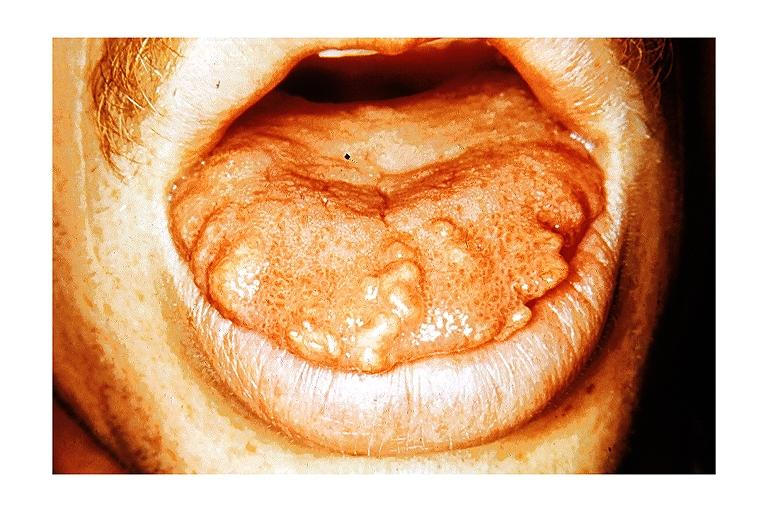s oral present?
Answer the question using a single word or phrase. Yes 